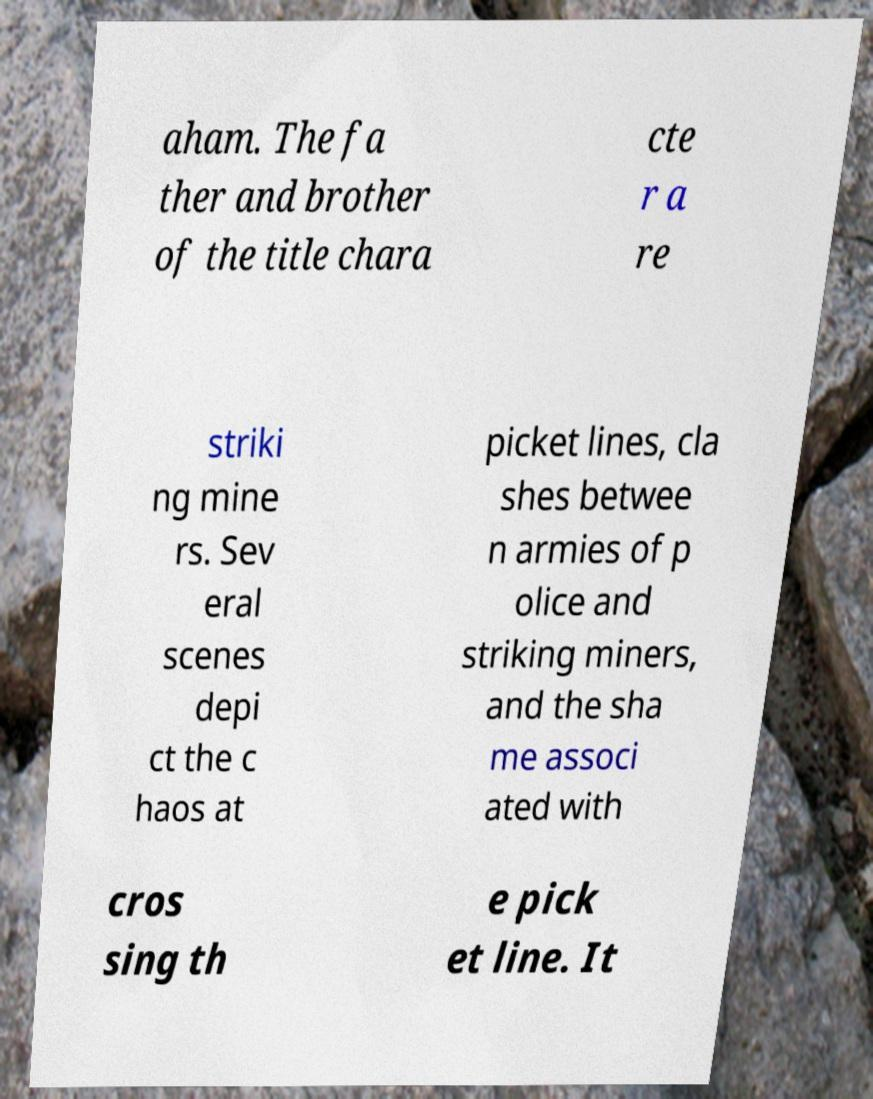There's text embedded in this image that I need extracted. Can you transcribe it verbatim? aham. The fa ther and brother of the title chara cte r a re striki ng mine rs. Sev eral scenes depi ct the c haos at picket lines, cla shes betwee n armies of p olice and striking miners, and the sha me associ ated with cros sing th e pick et line. It 